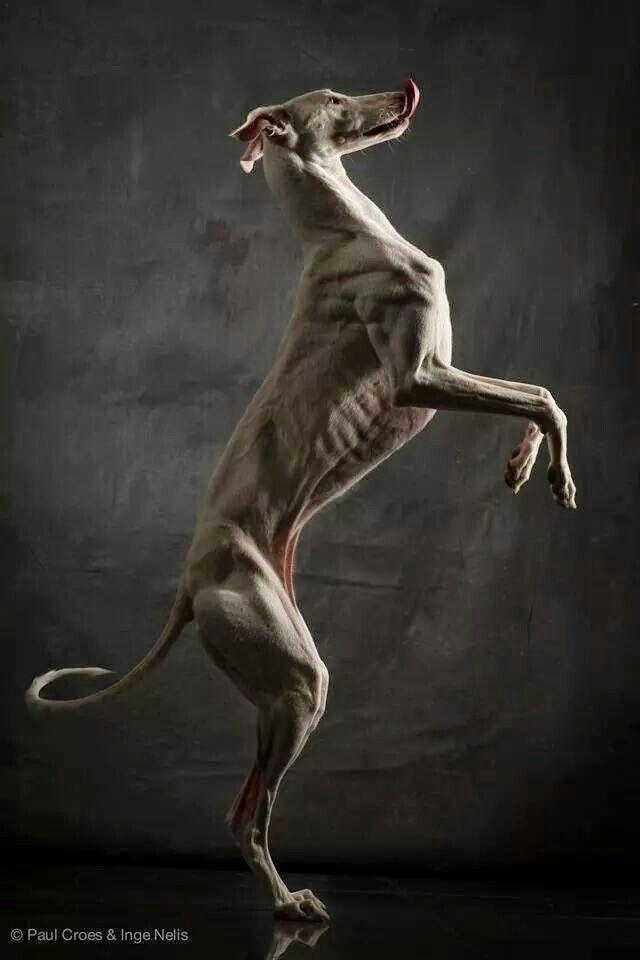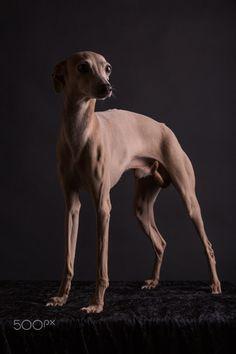The first image is the image on the left, the second image is the image on the right. Given the left and right images, does the statement "All the dogs in the images are posing for portraits wearing collars." hold true? Answer yes or no. No. 